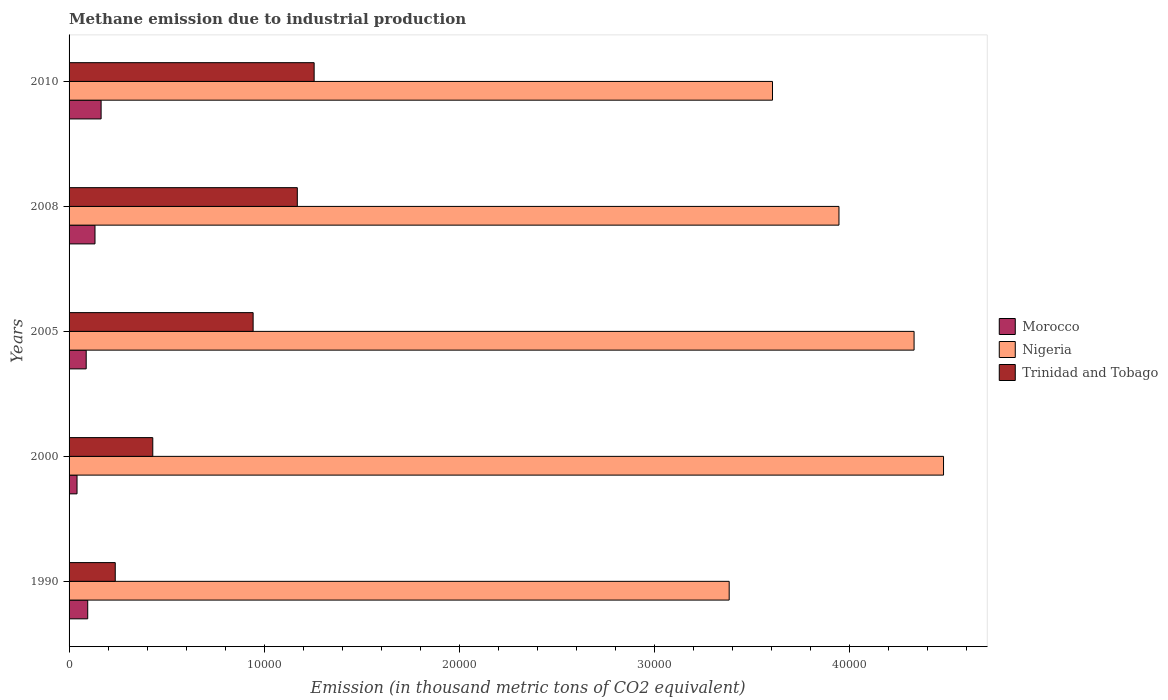How many different coloured bars are there?
Provide a succinct answer. 3. How many groups of bars are there?
Offer a very short reply. 5. Are the number of bars per tick equal to the number of legend labels?
Your response must be concise. Yes. Are the number of bars on each tick of the Y-axis equal?
Provide a succinct answer. Yes. How many bars are there on the 1st tick from the top?
Provide a succinct answer. 3. What is the label of the 1st group of bars from the top?
Your answer should be compact. 2010. What is the amount of methane emitted in Nigeria in 2010?
Provide a short and direct response. 3.61e+04. Across all years, what is the maximum amount of methane emitted in Trinidad and Tobago?
Ensure brevity in your answer.  1.26e+04. Across all years, what is the minimum amount of methane emitted in Morocco?
Ensure brevity in your answer.  407.6. In which year was the amount of methane emitted in Nigeria maximum?
Provide a succinct answer. 2000. In which year was the amount of methane emitted in Trinidad and Tobago minimum?
Make the answer very short. 1990. What is the total amount of methane emitted in Trinidad and Tobago in the graph?
Offer a terse response. 4.03e+04. What is the difference between the amount of methane emitted in Morocco in 2000 and that in 2005?
Ensure brevity in your answer.  -470.1. What is the difference between the amount of methane emitted in Nigeria in 1990 and the amount of methane emitted in Morocco in 2000?
Make the answer very short. 3.34e+04. What is the average amount of methane emitted in Trinidad and Tobago per year?
Offer a terse response. 8069.92. In the year 2010, what is the difference between the amount of methane emitted in Morocco and amount of methane emitted in Trinidad and Tobago?
Ensure brevity in your answer.  -1.09e+04. What is the ratio of the amount of methane emitted in Trinidad and Tobago in 1990 to that in 2005?
Give a very brief answer. 0.25. Is the difference between the amount of methane emitted in Morocco in 2005 and 2008 greater than the difference between the amount of methane emitted in Trinidad and Tobago in 2005 and 2008?
Ensure brevity in your answer.  Yes. What is the difference between the highest and the second highest amount of methane emitted in Trinidad and Tobago?
Offer a terse response. 862.5. What is the difference between the highest and the lowest amount of methane emitted in Trinidad and Tobago?
Your answer should be very brief. 1.02e+04. What does the 1st bar from the top in 2005 represents?
Give a very brief answer. Trinidad and Tobago. What does the 3rd bar from the bottom in 2005 represents?
Keep it short and to the point. Trinidad and Tobago. How many bars are there?
Keep it short and to the point. 15. How many years are there in the graph?
Offer a terse response. 5. What is the difference between two consecutive major ticks on the X-axis?
Provide a short and direct response. 10000. Does the graph contain any zero values?
Provide a short and direct response. No. Does the graph contain grids?
Provide a short and direct response. No. What is the title of the graph?
Your response must be concise. Methane emission due to industrial production. Does "Ghana" appear as one of the legend labels in the graph?
Provide a succinct answer. No. What is the label or title of the X-axis?
Provide a succinct answer. Emission (in thousand metric tons of CO2 equivalent). What is the Emission (in thousand metric tons of CO2 equivalent) in Morocco in 1990?
Ensure brevity in your answer.  955.4. What is the Emission (in thousand metric tons of CO2 equivalent) in Nigeria in 1990?
Provide a short and direct response. 3.38e+04. What is the Emission (in thousand metric tons of CO2 equivalent) of Trinidad and Tobago in 1990?
Make the answer very short. 2367.2. What is the Emission (in thousand metric tons of CO2 equivalent) of Morocco in 2000?
Offer a terse response. 407.6. What is the Emission (in thousand metric tons of CO2 equivalent) in Nigeria in 2000?
Your response must be concise. 4.48e+04. What is the Emission (in thousand metric tons of CO2 equivalent) of Trinidad and Tobago in 2000?
Provide a succinct answer. 4290.2. What is the Emission (in thousand metric tons of CO2 equivalent) in Morocco in 2005?
Your answer should be very brief. 877.7. What is the Emission (in thousand metric tons of CO2 equivalent) in Nigeria in 2005?
Keep it short and to the point. 4.33e+04. What is the Emission (in thousand metric tons of CO2 equivalent) in Trinidad and Tobago in 2005?
Your answer should be very brief. 9433.3. What is the Emission (in thousand metric tons of CO2 equivalent) of Morocco in 2008?
Make the answer very short. 1328.7. What is the Emission (in thousand metric tons of CO2 equivalent) of Nigeria in 2008?
Offer a very short reply. 3.95e+04. What is the Emission (in thousand metric tons of CO2 equivalent) in Trinidad and Tobago in 2008?
Offer a terse response. 1.17e+04. What is the Emission (in thousand metric tons of CO2 equivalent) in Morocco in 2010?
Offer a very short reply. 1641.9. What is the Emission (in thousand metric tons of CO2 equivalent) in Nigeria in 2010?
Make the answer very short. 3.61e+04. What is the Emission (in thousand metric tons of CO2 equivalent) in Trinidad and Tobago in 2010?
Give a very brief answer. 1.26e+04. Across all years, what is the maximum Emission (in thousand metric tons of CO2 equivalent) of Morocco?
Give a very brief answer. 1641.9. Across all years, what is the maximum Emission (in thousand metric tons of CO2 equivalent) of Nigeria?
Offer a very short reply. 4.48e+04. Across all years, what is the maximum Emission (in thousand metric tons of CO2 equivalent) of Trinidad and Tobago?
Your response must be concise. 1.26e+04. Across all years, what is the minimum Emission (in thousand metric tons of CO2 equivalent) in Morocco?
Provide a short and direct response. 407.6. Across all years, what is the minimum Emission (in thousand metric tons of CO2 equivalent) in Nigeria?
Your answer should be very brief. 3.38e+04. Across all years, what is the minimum Emission (in thousand metric tons of CO2 equivalent) of Trinidad and Tobago?
Your answer should be compact. 2367.2. What is the total Emission (in thousand metric tons of CO2 equivalent) in Morocco in the graph?
Give a very brief answer. 5211.3. What is the total Emission (in thousand metric tons of CO2 equivalent) of Nigeria in the graph?
Make the answer very short. 1.97e+05. What is the total Emission (in thousand metric tons of CO2 equivalent) in Trinidad and Tobago in the graph?
Make the answer very short. 4.03e+04. What is the difference between the Emission (in thousand metric tons of CO2 equivalent) in Morocco in 1990 and that in 2000?
Make the answer very short. 547.8. What is the difference between the Emission (in thousand metric tons of CO2 equivalent) of Nigeria in 1990 and that in 2000?
Your answer should be compact. -1.10e+04. What is the difference between the Emission (in thousand metric tons of CO2 equivalent) of Trinidad and Tobago in 1990 and that in 2000?
Your answer should be compact. -1923. What is the difference between the Emission (in thousand metric tons of CO2 equivalent) of Morocco in 1990 and that in 2005?
Your response must be concise. 77.7. What is the difference between the Emission (in thousand metric tons of CO2 equivalent) of Nigeria in 1990 and that in 2005?
Make the answer very short. -9476.4. What is the difference between the Emission (in thousand metric tons of CO2 equivalent) of Trinidad and Tobago in 1990 and that in 2005?
Your response must be concise. -7066.1. What is the difference between the Emission (in thousand metric tons of CO2 equivalent) in Morocco in 1990 and that in 2008?
Keep it short and to the point. -373.3. What is the difference between the Emission (in thousand metric tons of CO2 equivalent) in Nigeria in 1990 and that in 2008?
Keep it short and to the point. -5627.2. What is the difference between the Emission (in thousand metric tons of CO2 equivalent) in Trinidad and Tobago in 1990 and that in 2008?
Give a very brief answer. -9331. What is the difference between the Emission (in thousand metric tons of CO2 equivalent) of Morocco in 1990 and that in 2010?
Keep it short and to the point. -686.5. What is the difference between the Emission (in thousand metric tons of CO2 equivalent) of Nigeria in 1990 and that in 2010?
Give a very brief answer. -2220. What is the difference between the Emission (in thousand metric tons of CO2 equivalent) of Trinidad and Tobago in 1990 and that in 2010?
Your answer should be compact. -1.02e+04. What is the difference between the Emission (in thousand metric tons of CO2 equivalent) of Morocco in 2000 and that in 2005?
Give a very brief answer. -470.1. What is the difference between the Emission (in thousand metric tons of CO2 equivalent) in Nigeria in 2000 and that in 2005?
Your answer should be very brief. 1509.9. What is the difference between the Emission (in thousand metric tons of CO2 equivalent) of Trinidad and Tobago in 2000 and that in 2005?
Ensure brevity in your answer.  -5143.1. What is the difference between the Emission (in thousand metric tons of CO2 equivalent) of Morocco in 2000 and that in 2008?
Make the answer very short. -921.1. What is the difference between the Emission (in thousand metric tons of CO2 equivalent) of Nigeria in 2000 and that in 2008?
Provide a succinct answer. 5359.1. What is the difference between the Emission (in thousand metric tons of CO2 equivalent) in Trinidad and Tobago in 2000 and that in 2008?
Your response must be concise. -7408. What is the difference between the Emission (in thousand metric tons of CO2 equivalent) in Morocco in 2000 and that in 2010?
Your answer should be compact. -1234.3. What is the difference between the Emission (in thousand metric tons of CO2 equivalent) of Nigeria in 2000 and that in 2010?
Provide a short and direct response. 8766.3. What is the difference between the Emission (in thousand metric tons of CO2 equivalent) of Trinidad and Tobago in 2000 and that in 2010?
Offer a very short reply. -8270.5. What is the difference between the Emission (in thousand metric tons of CO2 equivalent) of Morocco in 2005 and that in 2008?
Ensure brevity in your answer.  -451. What is the difference between the Emission (in thousand metric tons of CO2 equivalent) of Nigeria in 2005 and that in 2008?
Ensure brevity in your answer.  3849.2. What is the difference between the Emission (in thousand metric tons of CO2 equivalent) of Trinidad and Tobago in 2005 and that in 2008?
Make the answer very short. -2264.9. What is the difference between the Emission (in thousand metric tons of CO2 equivalent) of Morocco in 2005 and that in 2010?
Your response must be concise. -764.2. What is the difference between the Emission (in thousand metric tons of CO2 equivalent) in Nigeria in 2005 and that in 2010?
Provide a short and direct response. 7256.4. What is the difference between the Emission (in thousand metric tons of CO2 equivalent) in Trinidad and Tobago in 2005 and that in 2010?
Offer a very short reply. -3127.4. What is the difference between the Emission (in thousand metric tons of CO2 equivalent) of Morocco in 2008 and that in 2010?
Make the answer very short. -313.2. What is the difference between the Emission (in thousand metric tons of CO2 equivalent) of Nigeria in 2008 and that in 2010?
Provide a short and direct response. 3407.2. What is the difference between the Emission (in thousand metric tons of CO2 equivalent) in Trinidad and Tobago in 2008 and that in 2010?
Offer a terse response. -862.5. What is the difference between the Emission (in thousand metric tons of CO2 equivalent) of Morocco in 1990 and the Emission (in thousand metric tons of CO2 equivalent) of Nigeria in 2000?
Provide a short and direct response. -4.39e+04. What is the difference between the Emission (in thousand metric tons of CO2 equivalent) in Morocco in 1990 and the Emission (in thousand metric tons of CO2 equivalent) in Trinidad and Tobago in 2000?
Your answer should be very brief. -3334.8. What is the difference between the Emission (in thousand metric tons of CO2 equivalent) in Nigeria in 1990 and the Emission (in thousand metric tons of CO2 equivalent) in Trinidad and Tobago in 2000?
Your response must be concise. 2.95e+04. What is the difference between the Emission (in thousand metric tons of CO2 equivalent) in Morocco in 1990 and the Emission (in thousand metric tons of CO2 equivalent) in Nigeria in 2005?
Provide a short and direct response. -4.24e+04. What is the difference between the Emission (in thousand metric tons of CO2 equivalent) of Morocco in 1990 and the Emission (in thousand metric tons of CO2 equivalent) of Trinidad and Tobago in 2005?
Provide a short and direct response. -8477.9. What is the difference between the Emission (in thousand metric tons of CO2 equivalent) of Nigeria in 1990 and the Emission (in thousand metric tons of CO2 equivalent) of Trinidad and Tobago in 2005?
Keep it short and to the point. 2.44e+04. What is the difference between the Emission (in thousand metric tons of CO2 equivalent) in Morocco in 1990 and the Emission (in thousand metric tons of CO2 equivalent) in Nigeria in 2008?
Make the answer very short. -3.85e+04. What is the difference between the Emission (in thousand metric tons of CO2 equivalent) in Morocco in 1990 and the Emission (in thousand metric tons of CO2 equivalent) in Trinidad and Tobago in 2008?
Your response must be concise. -1.07e+04. What is the difference between the Emission (in thousand metric tons of CO2 equivalent) in Nigeria in 1990 and the Emission (in thousand metric tons of CO2 equivalent) in Trinidad and Tobago in 2008?
Offer a terse response. 2.21e+04. What is the difference between the Emission (in thousand metric tons of CO2 equivalent) in Morocco in 1990 and the Emission (in thousand metric tons of CO2 equivalent) in Nigeria in 2010?
Your response must be concise. -3.51e+04. What is the difference between the Emission (in thousand metric tons of CO2 equivalent) of Morocco in 1990 and the Emission (in thousand metric tons of CO2 equivalent) of Trinidad and Tobago in 2010?
Ensure brevity in your answer.  -1.16e+04. What is the difference between the Emission (in thousand metric tons of CO2 equivalent) in Nigeria in 1990 and the Emission (in thousand metric tons of CO2 equivalent) in Trinidad and Tobago in 2010?
Give a very brief answer. 2.13e+04. What is the difference between the Emission (in thousand metric tons of CO2 equivalent) of Morocco in 2000 and the Emission (in thousand metric tons of CO2 equivalent) of Nigeria in 2005?
Your response must be concise. -4.29e+04. What is the difference between the Emission (in thousand metric tons of CO2 equivalent) of Morocco in 2000 and the Emission (in thousand metric tons of CO2 equivalent) of Trinidad and Tobago in 2005?
Offer a terse response. -9025.7. What is the difference between the Emission (in thousand metric tons of CO2 equivalent) of Nigeria in 2000 and the Emission (in thousand metric tons of CO2 equivalent) of Trinidad and Tobago in 2005?
Your answer should be very brief. 3.54e+04. What is the difference between the Emission (in thousand metric tons of CO2 equivalent) in Morocco in 2000 and the Emission (in thousand metric tons of CO2 equivalent) in Nigeria in 2008?
Offer a very short reply. -3.91e+04. What is the difference between the Emission (in thousand metric tons of CO2 equivalent) of Morocco in 2000 and the Emission (in thousand metric tons of CO2 equivalent) of Trinidad and Tobago in 2008?
Make the answer very short. -1.13e+04. What is the difference between the Emission (in thousand metric tons of CO2 equivalent) of Nigeria in 2000 and the Emission (in thousand metric tons of CO2 equivalent) of Trinidad and Tobago in 2008?
Keep it short and to the point. 3.31e+04. What is the difference between the Emission (in thousand metric tons of CO2 equivalent) in Morocco in 2000 and the Emission (in thousand metric tons of CO2 equivalent) in Nigeria in 2010?
Your answer should be very brief. -3.56e+04. What is the difference between the Emission (in thousand metric tons of CO2 equivalent) of Morocco in 2000 and the Emission (in thousand metric tons of CO2 equivalent) of Trinidad and Tobago in 2010?
Offer a terse response. -1.22e+04. What is the difference between the Emission (in thousand metric tons of CO2 equivalent) of Nigeria in 2000 and the Emission (in thousand metric tons of CO2 equivalent) of Trinidad and Tobago in 2010?
Make the answer very short. 3.23e+04. What is the difference between the Emission (in thousand metric tons of CO2 equivalent) in Morocco in 2005 and the Emission (in thousand metric tons of CO2 equivalent) in Nigeria in 2008?
Make the answer very short. -3.86e+04. What is the difference between the Emission (in thousand metric tons of CO2 equivalent) of Morocco in 2005 and the Emission (in thousand metric tons of CO2 equivalent) of Trinidad and Tobago in 2008?
Provide a succinct answer. -1.08e+04. What is the difference between the Emission (in thousand metric tons of CO2 equivalent) of Nigeria in 2005 and the Emission (in thousand metric tons of CO2 equivalent) of Trinidad and Tobago in 2008?
Provide a short and direct response. 3.16e+04. What is the difference between the Emission (in thousand metric tons of CO2 equivalent) of Morocco in 2005 and the Emission (in thousand metric tons of CO2 equivalent) of Nigeria in 2010?
Provide a succinct answer. -3.52e+04. What is the difference between the Emission (in thousand metric tons of CO2 equivalent) of Morocco in 2005 and the Emission (in thousand metric tons of CO2 equivalent) of Trinidad and Tobago in 2010?
Offer a terse response. -1.17e+04. What is the difference between the Emission (in thousand metric tons of CO2 equivalent) in Nigeria in 2005 and the Emission (in thousand metric tons of CO2 equivalent) in Trinidad and Tobago in 2010?
Make the answer very short. 3.07e+04. What is the difference between the Emission (in thousand metric tons of CO2 equivalent) in Morocco in 2008 and the Emission (in thousand metric tons of CO2 equivalent) in Nigeria in 2010?
Make the answer very short. -3.47e+04. What is the difference between the Emission (in thousand metric tons of CO2 equivalent) in Morocco in 2008 and the Emission (in thousand metric tons of CO2 equivalent) in Trinidad and Tobago in 2010?
Offer a very short reply. -1.12e+04. What is the difference between the Emission (in thousand metric tons of CO2 equivalent) in Nigeria in 2008 and the Emission (in thousand metric tons of CO2 equivalent) in Trinidad and Tobago in 2010?
Offer a terse response. 2.69e+04. What is the average Emission (in thousand metric tons of CO2 equivalent) of Morocco per year?
Your answer should be very brief. 1042.26. What is the average Emission (in thousand metric tons of CO2 equivalent) of Nigeria per year?
Your answer should be very brief. 3.95e+04. What is the average Emission (in thousand metric tons of CO2 equivalent) in Trinidad and Tobago per year?
Provide a succinct answer. 8069.92. In the year 1990, what is the difference between the Emission (in thousand metric tons of CO2 equivalent) of Morocco and Emission (in thousand metric tons of CO2 equivalent) of Nigeria?
Ensure brevity in your answer.  -3.29e+04. In the year 1990, what is the difference between the Emission (in thousand metric tons of CO2 equivalent) in Morocco and Emission (in thousand metric tons of CO2 equivalent) in Trinidad and Tobago?
Offer a terse response. -1411.8. In the year 1990, what is the difference between the Emission (in thousand metric tons of CO2 equivalent) of Nigeria and Emission (in thousand metric tons of CO2 equivalent) of Trinidad and Tobago?
Give a very brief answer. 3.15e+04. In the year 2000, what is the difference between the Emission (in thousand metric tons of CO2 equivalent) in Morocco and Emission (in thousand metric tons of CO2 equivalent) in Nigeria?
Offer a very short reply. -4.44e+04. In the year 2000, what is the difference between the Emission (in thousand metric tons of CO2 equivalent) of Morocco and Emission (in thousand metric tons of CO2 equivalent) of Trinidad and Tobago?
Your answer should be very brief. -3882.6. In the year 2000, what is the difference between the Emission (in thousand metric tons of CO2 equivalent) of Nigeria and Emission (in thousand metric tons of CO2 equivalent) of Trinidad and Tobago?
Provide a succinct answer. 4.05e+04. In the year 2005, what is the difference between the Emission (in thousand metric tons of CO2 equivalent) of Morocco and Emission (in thousand metric tons of CO2 equivalent) of Nigeria?
Your response must be concise. -4.24e+04. In the year 2005, what is the difference between the Emission (in thousand metric tons of CO2 equivalent) of Morocco and Emission (in thousand metric tons of CO2 equivalent) of Trinidad and Tobago?
Make the answer very short. -8555.6. In the year 2005, what is the difference between the Emission (in thousand metric tons of CO2 equivalent) in Nigeria and Emission (in thousand metric tons of CO2 equivalent) in Trinidad and Tobago?
Offer a terse response. 3.39e+04. In the year 2008, what is the difference between the Emission (in thousand metric tons of CO2 equivalent) of Morocco and Emission (in thousand metric tons of CO2 equivalent) of Nigeria?
Ensure brevity in your answer.  -3.81e+04. In the year 2008, what is the difference between the Emission (in thousand metric tons of CO2 equivalent) in Morocco and Emission (in thousand metric tons of CO2 equivalent) in Trinidad and Tobago?
Give a very brief answer. -1.04e+04. In the year 2008, what is the difference between the Emission (in thousand metric tons of CO2 equivalent) in Nigeria and Emission (in thousand metric tons of CO2 equivalent) in Trinidad and Tobago?
Ensure brevity in your answer.  2.78e+04. In the year 2010, what is the difference between the Emission (in thousand metric tons of CO2 equivalent) in Morocco and Emission (in thousand metric tons of CO2 equivalent) in Nigeria?
Keep it short and to the point. -3.44e+04. In the year 2010, what is the difference between the Emission (in thousand metric tons of CO2 equivalent) of Morocco and Emission (in thousand metric tons of CO2 equivalent) of Trinidad and Tobago?
Provide a succinct answer. -1.09e+04. In the year 2010, what is the difference between the Emission (in thousand metric tons of CO2 equivalent) of Nigeria and Emission (in thousand metric tons of CO2 equivalent) of Trinidad and Tobago?
Offer a very short reply. 2.35e+04. What is the ratio of the Emission (in thousand metric tons of CO2 equivalent) of Morocco in 1990 to that in 2000?
Offer a very short reply. 2.34. What is the ratio of the Emission (in thousand metric tons of CO2 equivalent) of Nigeria in 1990 to that in 2000?
Provide a short and direct response. 0.75. What is the ratio of the Emission (in thousand metric tons of CO2 equivalent) of Trinidad and Tobago in 1990 to that in 2000?
Your answer should be compact. 0.55. What is the ratio of the Emission (in thousand metric tons of CO2 equivalent) of Morocco in 1990 to that in 2005?
Ensure brevity in your answer.  1.09. What is the ratio of the Emission (in thousand metric tons of CO2 equivalent) in Nigeria in 1990 to that in 2005?
Make the answer very short. 0.78. What is the ratio of the Emission (in thousand metric tons of CO2 equivalent) in Trinidad and Tobago in 1990 to that in 2005?
Give a very brief answer. 0.25. What is the ratio of the Emission (in thousand metric tons of CO2 equivalent) of Morocco in 1990 to that in 2008?
Your answer should be compact. 0.72. What is the ratio of the Emission (in thousand metric tons of CO2 equivalent) of Nigeria in 1990 to that in 2008?
Ensure brevity in your answer.  0.86. What is the ratio of the Emission (in thousand metric tons of CO2 equivalent) of Trinidad and Tobago in 1990 to that in 2008?
Give a very brief answer. 0.2. What is the ratio of the Emission (in thousand metric tons of CO2 equivalent) of Morocco in 1990 to that in 2010?
Your answer should be compact. 0.58. What is the ratio of the Emission (in thousand metric tons of CO2 equivalent) in Nigeria in 1990 to that in 2010?
Offer a very short reply. 0.94. What is the ratio of the Emission (in thousand metric tons of CO2 equivalent) of Trinidad and Tobago in 1990 to that in 2010?
Offer a terse response. 0.19. What is the ratio of the Emission (in thousand metric tons of CO2 equivalent) of Morocco in 2000 to that in 2005?
Keep it short and to the point. 0.46. What is the ratio of the Emission (in thousand metric tons of CO2 equivalent) in Nigeria in 2000 to that in 2005?
Offer a very short reply. 1.03. What is the ratio of the Emission (in thousand metric tons of CO2 equivalent) in Trinidad and Tobago in 2000 to that in 2005?
Your answer should be very brief. 0.45. What is the ratio of the Emission (in thousand metric tons of CO2 equivalent) of Morocco in 2000 to that in 2008?
Provide a succinct answer. 0.31. What is the ratio of the Emission (in thousand metric tons of CO2 equivalent) of Nigeria in 2000 to that in 2008?
Provide a short and direct response. 1.14. What is the ratio of the Emission (in thousand metric tons of CO2 equivalent) in Trinidad and Tobago in 2000 to that in 2008?
Your answer should be compact. 0.37. What is the ratio of the Emission (in thousand metric tons of CO2 equivalent) of Morocco in 2000 to that in 2010?
Offer a very short reply. 0.25. What is the ratio of the Emission (in thousand metric tons of CO2 equivalent) in Nigeria in 2000 to that in 2010?
Provide a short and direct response. 1.24. What is the ratio of the Emission (in thousand metric tons of CO2 equivalent) in Trinidad and Tobago in 2000 to that in 2010?
Your answer should be very brief. 0.34. What is the ratio of the Emission (in thousand metric tons of CO2 equivalent) of Morocco in 2005 to that in 2008?
Make the answer very short. 0.66. What is the ratio of the Emission (in thousand metric tons of CO2 equivalent) of Nigeria in 2005 to that in 2008?
Your response must be concise. 1.1. What is the ratio of the Emission (in thousand metric tons of CO2 equivalent) of Trinidad and Tobago in 2005 to that in 2008?
Your answer should be compact. 0.81. What is the ratio of the Emission (in thousand metric tons of CO2 equivalent) of Morocco in 2005 to that in 2010?
Offer a terse response. 0.53. What is the ratio of the Emission (in thousand metric tons of CO2 equivalent) of Nigeria in 2005 to that in 2010?
Ensure brevity in your answer.  1.2. What is the ratio of the Emission (in thousand metric tons of CO2 equivalent) in Trinidad and Tobago in 2005 to that in 2010?
Provide a short and direct response. 0.75. What is the ratio of the Emission (in thousand metric tons of CO2 equivalent) of Morocco in 2008 to that in 2010?
Give a very brief answer. 0.81. What is the ratio of the Emission (in thousand metric tons of CO2 equivalent) in Nigeria in 2008 to that in 2010?
Your answer should be compact. 1.09. What is the ratio of the Emission (in thousand metric tons of CO2 equivalent) of Trinidad and Tobago in 2008 to that in 2010?
Make the answer very short. 0.93. What is the difference between the highest and the second highest Emission (in thousand metric tons of CO2 equivalent) of Morocco?
Your answer should be very brief. 313.2. What is the difference between the highest and the second highest Emission (in thousand metric tons of CO2 equivalent) of Nigeria?
Provide a succinct answer. 1509.9. What is the difference between the highest and the second highest Emission (in thousand metric tons of CO2 equivalent) in Trinidad and Tobago?
Ensure brevity in your answer.  862.5. What is the difference between the highest and the lowest Emission (in thousand metric tons of CO2 equivalent) in Morocco?
Offer a terse response. 1234.3. What is the difference between the highest and the lowest Emission (in thousand metric tons of CO2 equivalent) in Nigeria?
Give a very brief answer. 1.10e+04. What is the difference between the highest and the lowest Emission (in thousand metric tons of CO2 equivalent) of Trinidad and Tobago?
Your answer should be compact. 1.02e+04. 